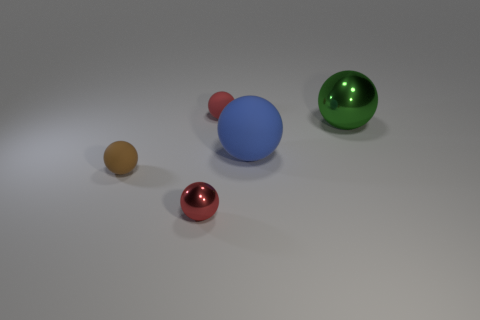How many spheres are there in the image? There are five spheres in the image, each with a different size and color. 